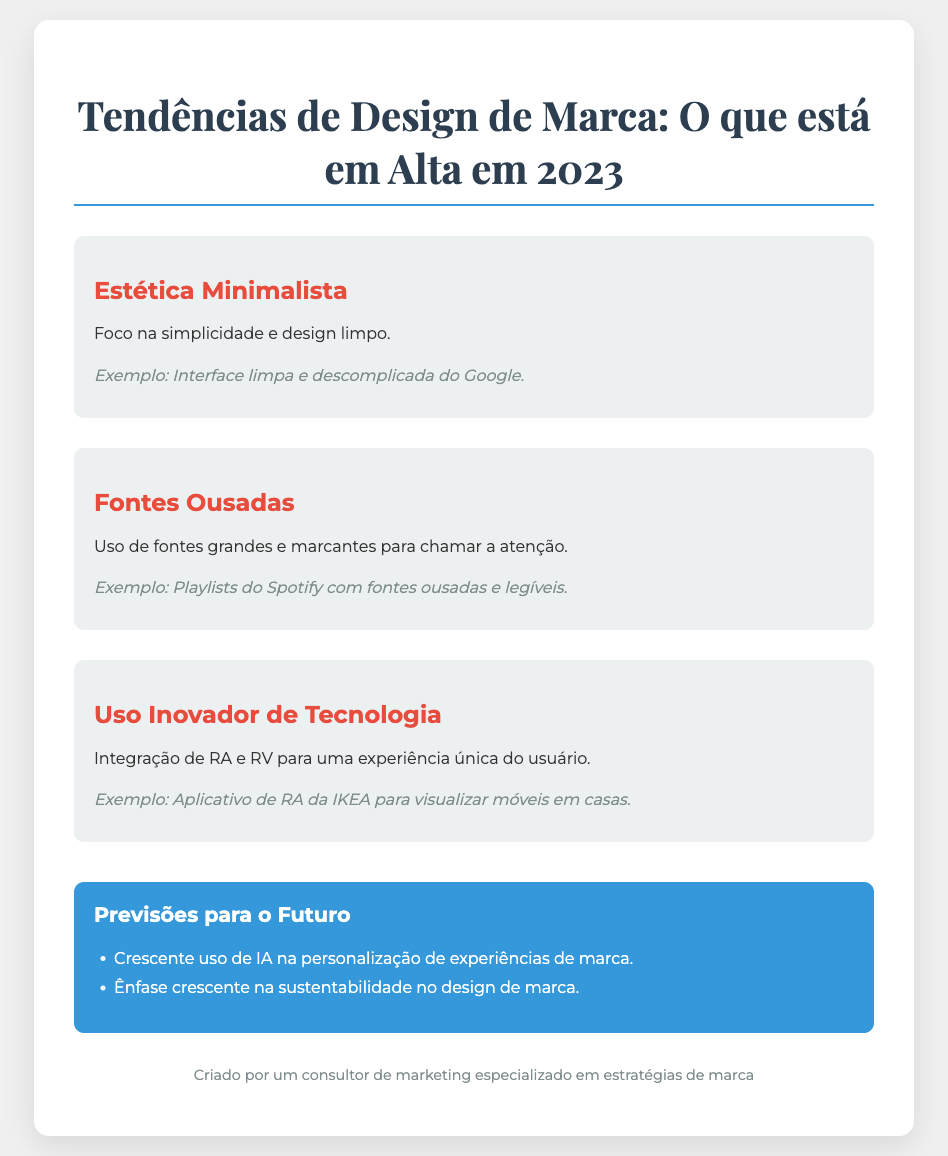Qual é o título do poster? O título do poster é a principal declaração que resuma o tema abordado, que é "Tendências de Design de Marca: O que está em Alta em 2023".
Answer: Tendências de Design de Marca: O que está em Alta em 2023 Quantas tendências de design são apresentadas no poster? O poster apresenta três tendências distintas de design de marca.
Answer: 3 Qual é um exemplo da estética minimalista? O exemplo dado para a estética minimalista é a interface limpa e descomplicada do Google.
Answer: Interface limpa e descomplicada do Google O que é destacado como uma previsões para o futuro do design de marca? Uma das previsões destacadas é o crescente uso de IA na personalização de experiências de marca.
Answer: Crescente uso de IA na personalização de experiências de marca Qual é a cor do título do poster? A cor do título do poster é um tom escuro, que pode ser descrito como um azul-escuro.
Answer: Azul-escuro Qual fonte é mencionada como um exemplo de fontes ousadas? O poster menciona as playlists do Spotify como um exemplo de uso de fontes ousadas.
Answer: Playlists do Spotify Qual é o design de fundo do poster? O design de fundo do poster é em tom claro, especificamente um cinza claro.
Answer: Cinza claro Que tecnologia é citada como sendo inovadora no design de marca? A integração de realidade aumentada (RA) e realidade virtual (RV) é citada como inovadora no design de marca.
Answer: Realidade aumentada (RA) e realidade virtual (RV) 